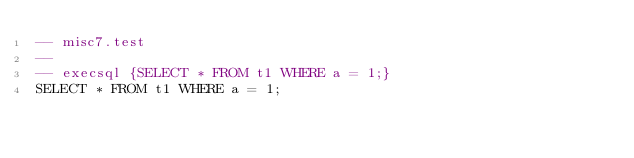<code> <loc_0><loc_0><loc_500><loc_500><_SQL_>-- misc7.test
-- 
-- execsql {SELECT * FROM t1 WHERE a = 1;}
SELECT * FROM t1 WHERE a = 1;</code> 